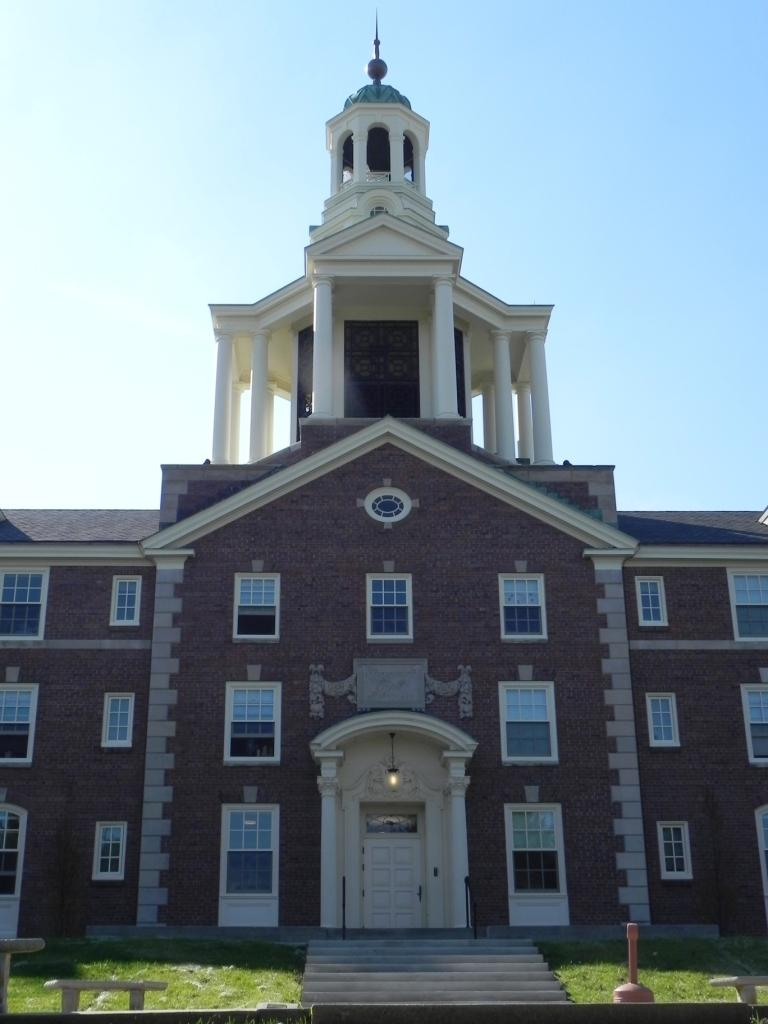What type of structure is in the image? There is a building in the image. Can you describe any features of the building? A light is visible in the building. What is visible at the top of the image? The sky is visible at the top of the image. What architectural elements are present at the bottom of the image? There are steps and a bench at the bottom of the image. What else can be seen at the bottom of the image? A small pole is visible at the bottom of the image. What type of jewel is being used for healing in the image? There is no jewel present in the image, and therefore no healing is taking place. What type of hospital is depicted in the image? There is no hospital depicted in the image; it features a building with a light inside. 